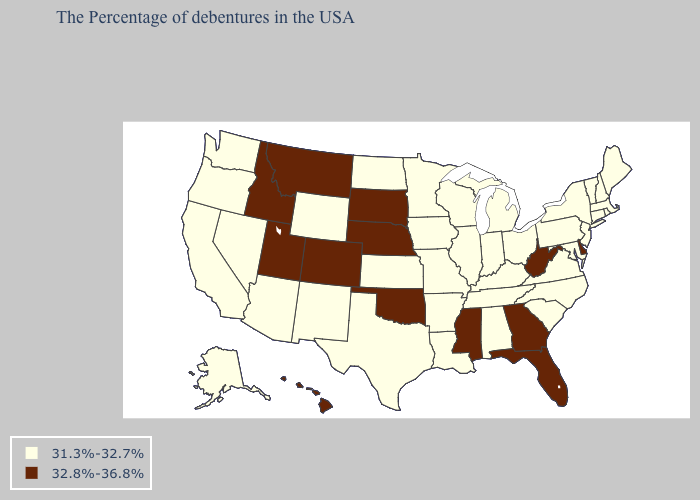Does Wyoming have a lower value than Alaska?
Be succinct. No. Name the states that have a value in the range 32.8%-36.8%?
Concise answer only. Delaware, West Virginia, Florida, Georgia, Mississippi, Nebraska, Oklahoma, South Dakota, Colorado, Utah, Montana, Idaho, Hawaii. What is the lowest value in the USA?
Answer briefly. 31.3%-32.7%. Name the states that have a value in the range 31.3%-32.7%?
Give a very brief answer. Maine, Massachusetts, Rhode Island, New Hampshire, Vermont, Connecticut, New York, New Jersey, Maryland, Pennsylvania, Virginia, North Carolina, South Carolina, Ohio, Michigan, Kentucky, Indiana, Alabama, Tennessee, Wisconsin, Illinois, Louisiana, Missouri, Arkansas, Minnesota, Iowa, Kansas, Texas, North Dakota, Wyoming, New Mexico, Arizona, Nevada, California, Washington, Oregon, Alaska. Name the states that have a value in the range 31.3%-32.7%?
Answer briefly. Maine, Massachusetts, Rhode Island, New Hampshire, Vermont, Connecticut, New York, New Jersey, Maryland, Pennsylvania, Virginia, North Carolina, South Carolina, Ohio, Michigan, Kentucky, Indiana, Alabama, Tennessee, Wisconsin, Illinois, Louisiana, Missouri, Arkansas, Minnesota, Iowa, Kansas, Texas, North Dakota, Wyoming, New Mexico, Arizona, Nevada, California, Washington, Oregon, Alaska. Does the first symbol in the legend represent the smallest category?
Short answer required. Yes. Among the states that border Indiana , which have the highest value?
Be succinct. Ohio, Michigan, Kentucky, Illinois. Does the map have missing data?
Be succinct. No. What is the value of Wisconsin?
Short answer required. 31.3%-32.7%. What is the value of Wyoming?
Write a very short answer. 31.3%-32.7%. Does Tennessee have the lowest value in the South?
Answer briefly. Yes. Which states hav the highest value in the West?
Quick response, please. Colorado, Utah, Montana, Idaho, Hawaii. Name the states that have a value in the range 31.3%-32.7%?
Answer briefly. Maine, Massachusetts, Rhode Island, New Hampshire, Vermont, Connecticut, New York, New Jersey, Maryland, Pennsylvania, Virginia, North Carolina, South Carolina, Ohio, Michigan, Kentucky, Indiana, Alabama, Tennessee, Wisconsin, Illinois, Louisiana, Missouri, Arkansas, Minnesota, Iowa, Kansas, Texas, North Dakota, Wyoming, New Mexico, Arizona, Nevada, California, Washington, Oregon, Alaska. What is the highest value in the South ?
Be succinct. 32.8%-36.8%. Name the states that have a value in the range 32.8%-36.8%?
Be succinct. Delaware, West Virginia, Florida, Georgia, Mississippi, Nebraska, Oklahoma, South Dakota, Colorado, Utah, Montana, Idaho, Hawaii. 